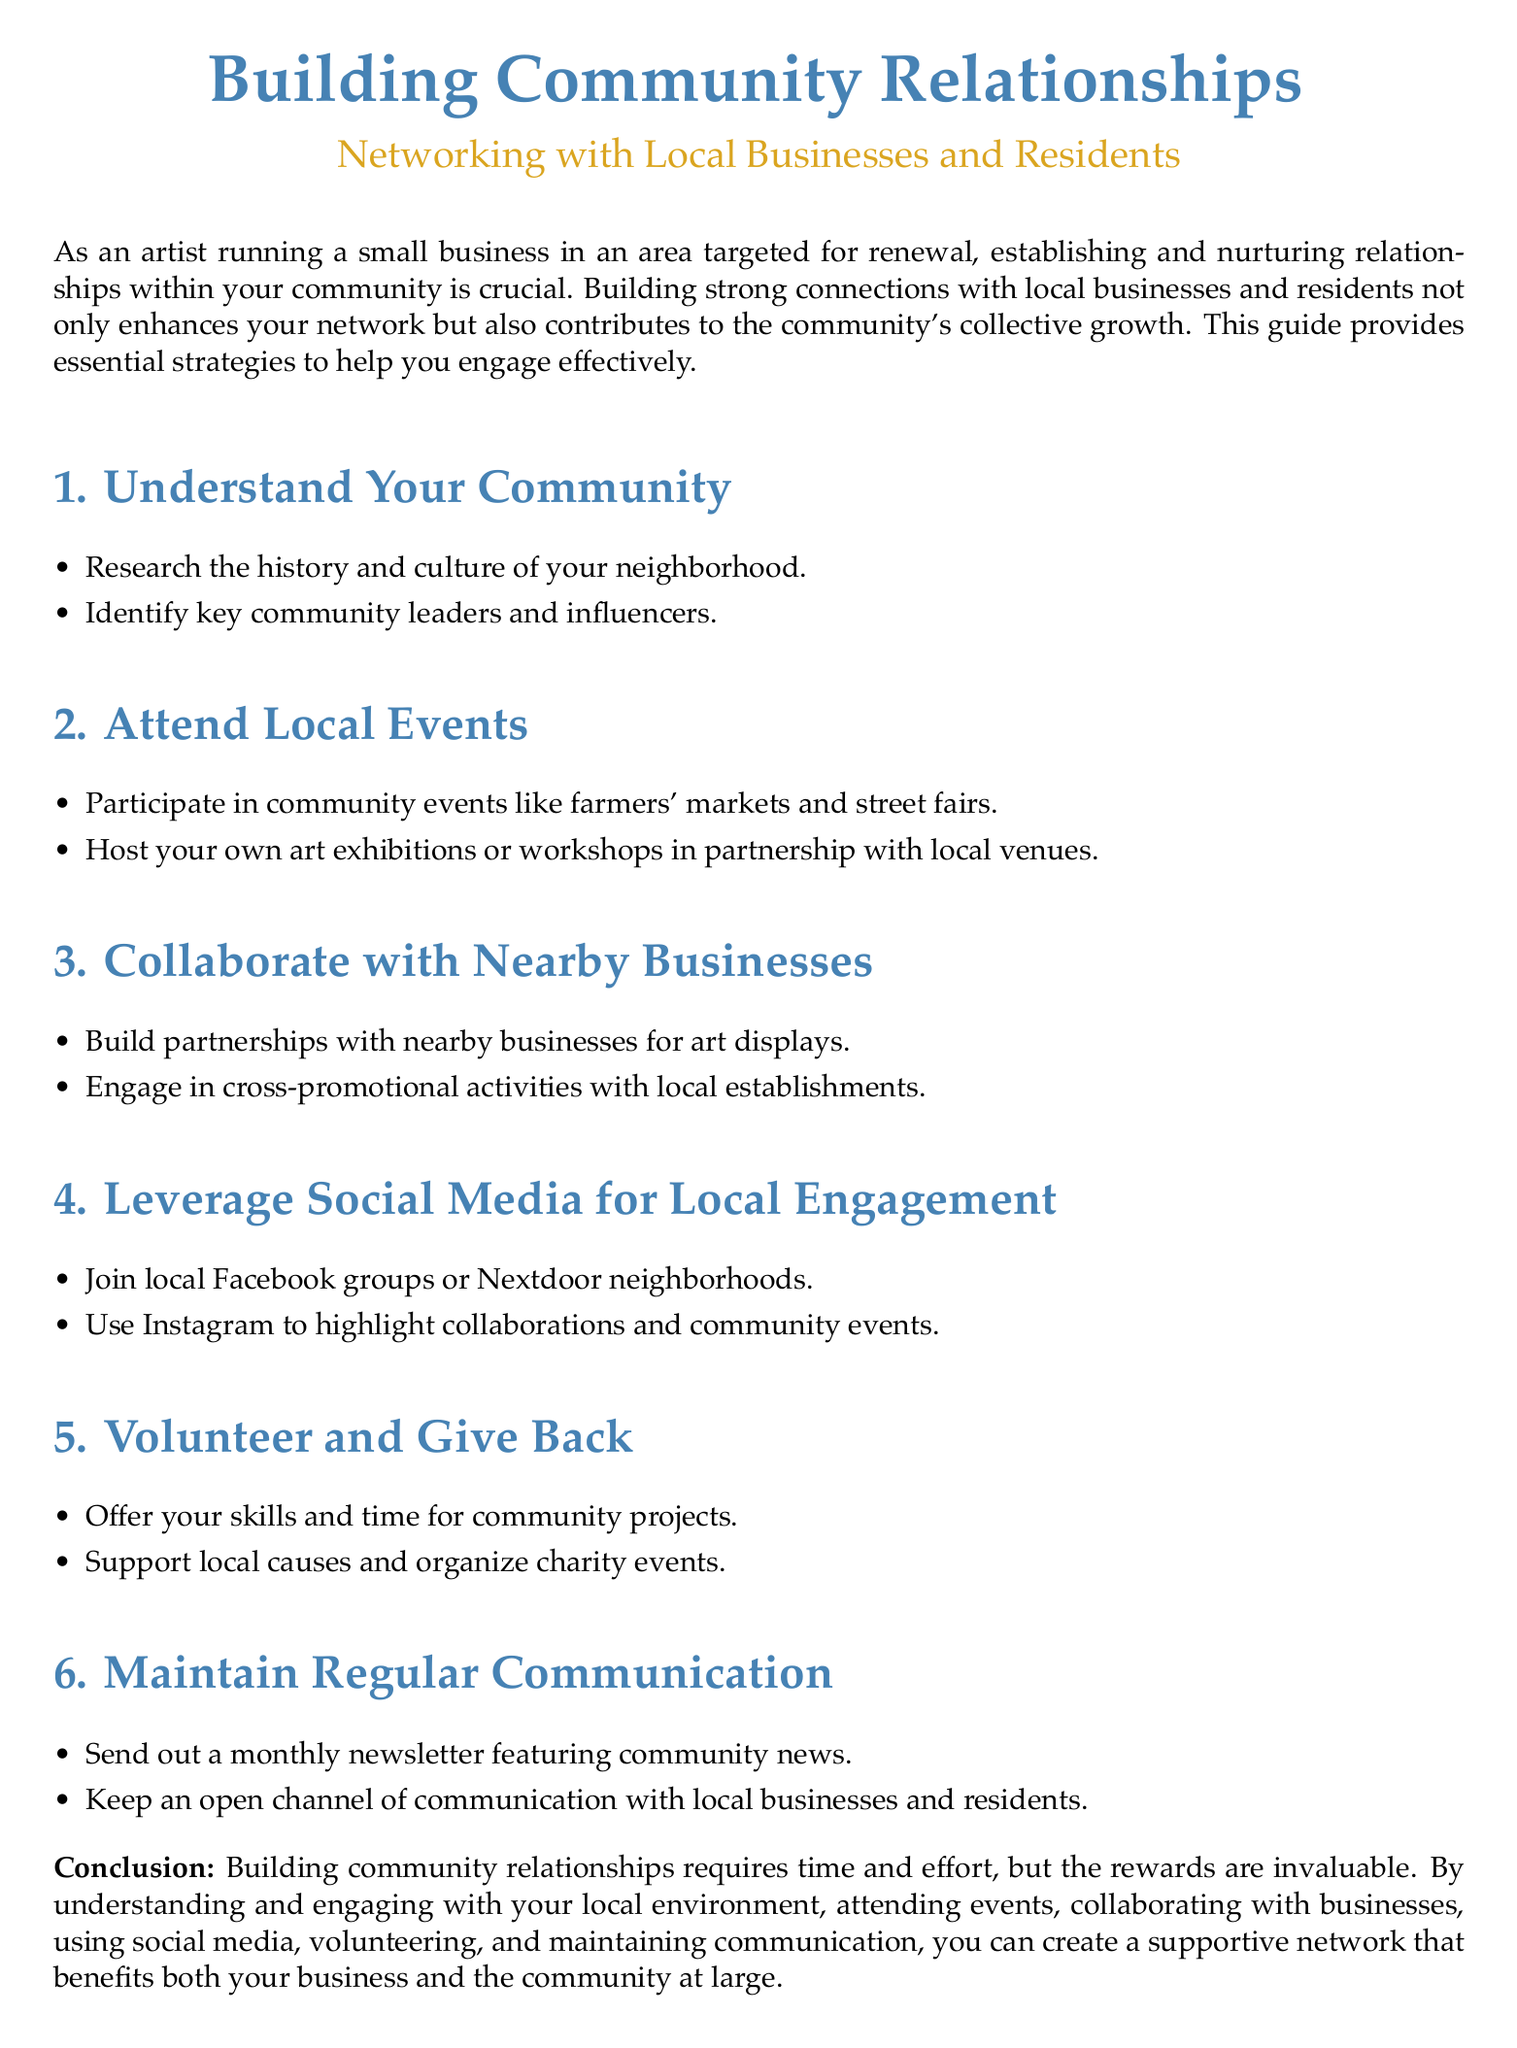What is the title of the document? The title of the document is prominently displayed at the top, summarizing its purpose.
Answer: Building Community Relationships What is one way to understand your community? The document suggests specific actions for understanding the community, which includes multiple approaches.
Answer: Research the history and culture of your neighborhood Name a type of event that artists should attend. The document lists various community events that would be beneficial for engagement.
Answer: Farmers' markets What should artists do to collaborate with nearby businesses? The document provides suggestions for partnerships and activities to enhance collaboration.
Answer: Build partnerships with nearby businesses for art displays List one social media platform mentioned for local engagement. The document specifies social media platforms as a way to connect with the community.
Answer: Instagram What is one way to maintain regular communication? The document outlines methods for keeping in touch with community members and businesses.
Answer: Send out a monthly newsletter featuring community news How many main strategies are outlined in the guide? The document is organized into distinct sections, each identified with a numbered strategy.
Answer: Six What is the color of the section titles? The document has a distinct style for its section titles which includes color coding.
Answer: Artblue What is the conclusion about building community relationships? The conclusion summarizes the overall message and the importance of community engagement in a few specific points.
Answer: The rewards are invaluable 